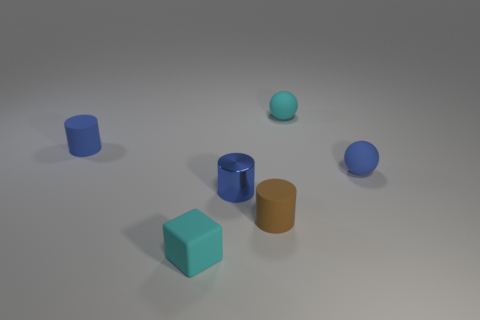Subtract all blue metal cylinders. How many cylinders are left? 2 Subtract all brown spheres. How many blue cylinders are left? 2 Add 4 tiny cyan rubber cubes. How many objects exist? 10 Subtract all balls. How many objects are left? 4 Subtract 1 cubes. How many cubes are left? 0 Subtract 0 green spheres. How many objects are left? 6 Subtract all gray cylinders. Subtract all purple blocks. How many cylinders are left? 3 Subtract all tiny cyan things. Subtract all cyan rubber objects. How many objects are left? 2 Add 6 cyan blocks. How many cyan blocks are left? 7 Add 6 tiny cyan matte objects. How many tiny cyan matte objects exist? 8 